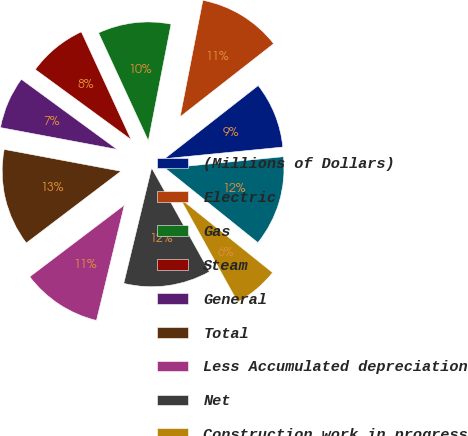Convert chart. <chart><loc_0><loc_0><loc_500><loc_500><pie_chart><fcel>(Millions of Dollars)<fcel>Electric<fcel>Gas<fcel>Steam<fcel>General<fcel>Total<fcel>Less Accumulated depreciation<fcel>Net<fcel>Construction work in progress<fcel>Net Utility Plant<nl><fcel>9.0%<fcel>11.37%<fcel>9.95%<fcel>8.06%<fcel>7.11%<fcel>13.27%<fcel>10.9%<fcel>11.85%<fcel>6.16%<fcel>12.32%<nl></chart> 